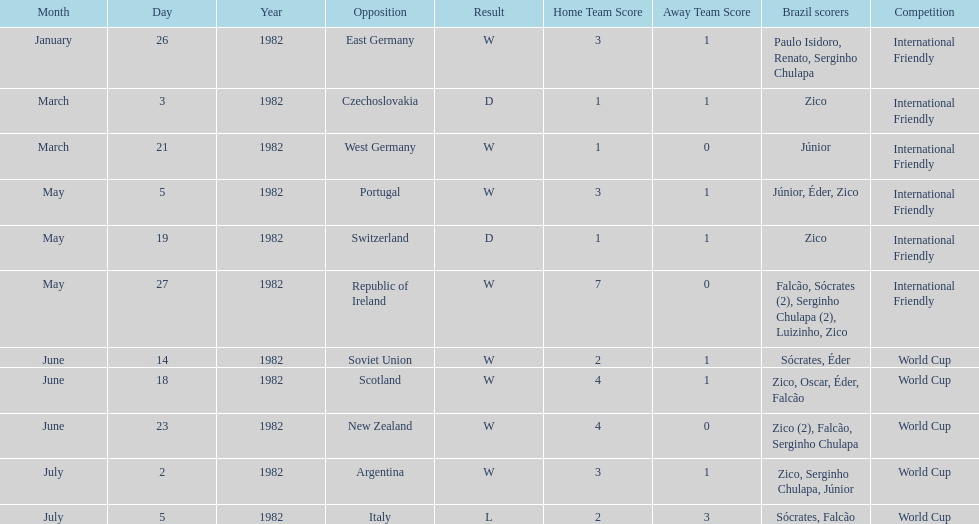Who was this team's next opponent after facing the soviet union on june 14? Scotland. 